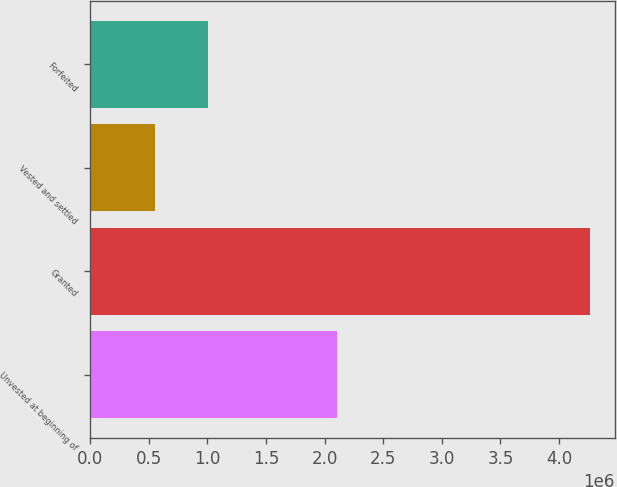<chart> <loc_0><loc_0><loc_500><loc_500><bar_chart><fcel>Unvested at beginning of<fcel>Granted<fcel>Vested and settled<fcel>Forfeited<nl><fcel>2.10733e+06<fcel>4.26228e+06<fcel>548510<fcel>1.00423e+06<nl></chart> 